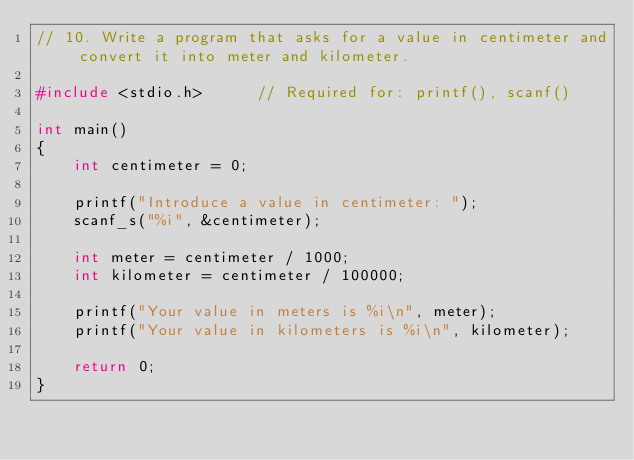Convert code to text. <code><loc_0><loc_0><loc_500><loc_500><_C_>// 10. Write a program that asks for a value in centimeter and convert it into meter and kilometer.

#include <stdio.h>		// Required for: printf(), scanf()

int main()
{
	int centimeter = 0;

	printf("Introduce a value in centimeter: ");
	scanf_s("%i", &centimeter);

	int meter = centimeter / 1000;
	int kilometer = centimeter / 100000;

	printf("Your value in meters is %i\n", meter);
	printf("Your value in kilometers is %i\n", kilometer);

	return 0;
}</code> 